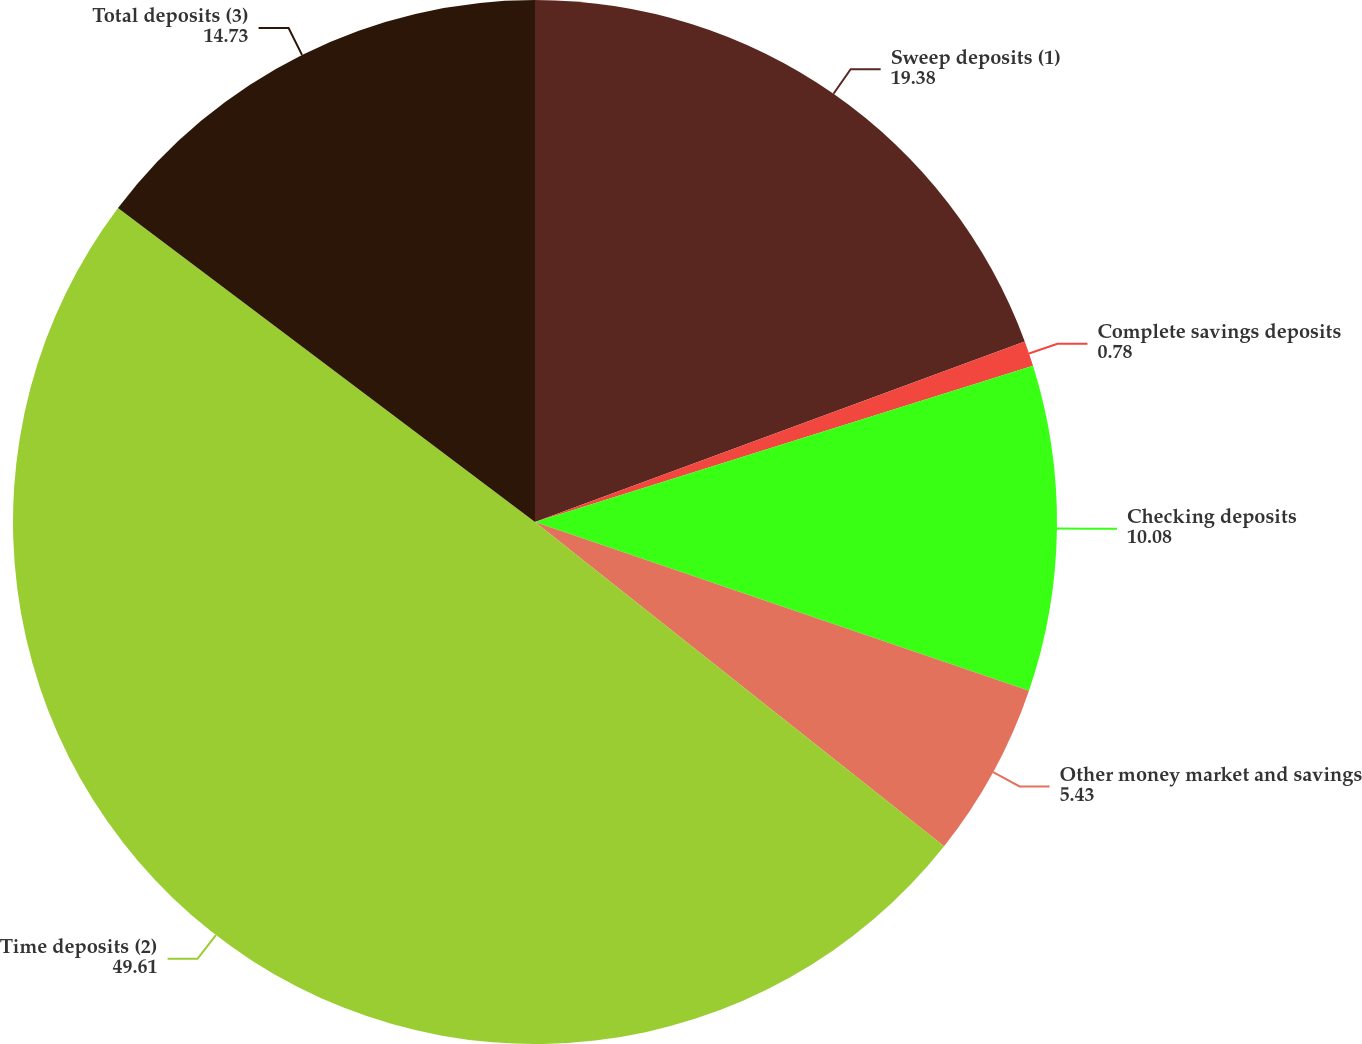Convert chart. <chart><loc_0><loc_0><loc_500><loc_500><pie_chart><fcel>Sweep deposits (1)<fcel>Complete savings deposits<fcel>Checking deposits<fcel>Other money market and savings<fcel>Time deposits (2)<fcel>Total deposits (3)<nl><fcel>19.38%<fcel>0.78%<fcel>10.08%<fcel>5.43%<fcel>49.61%<fcel>14.73%<nl></chart> 